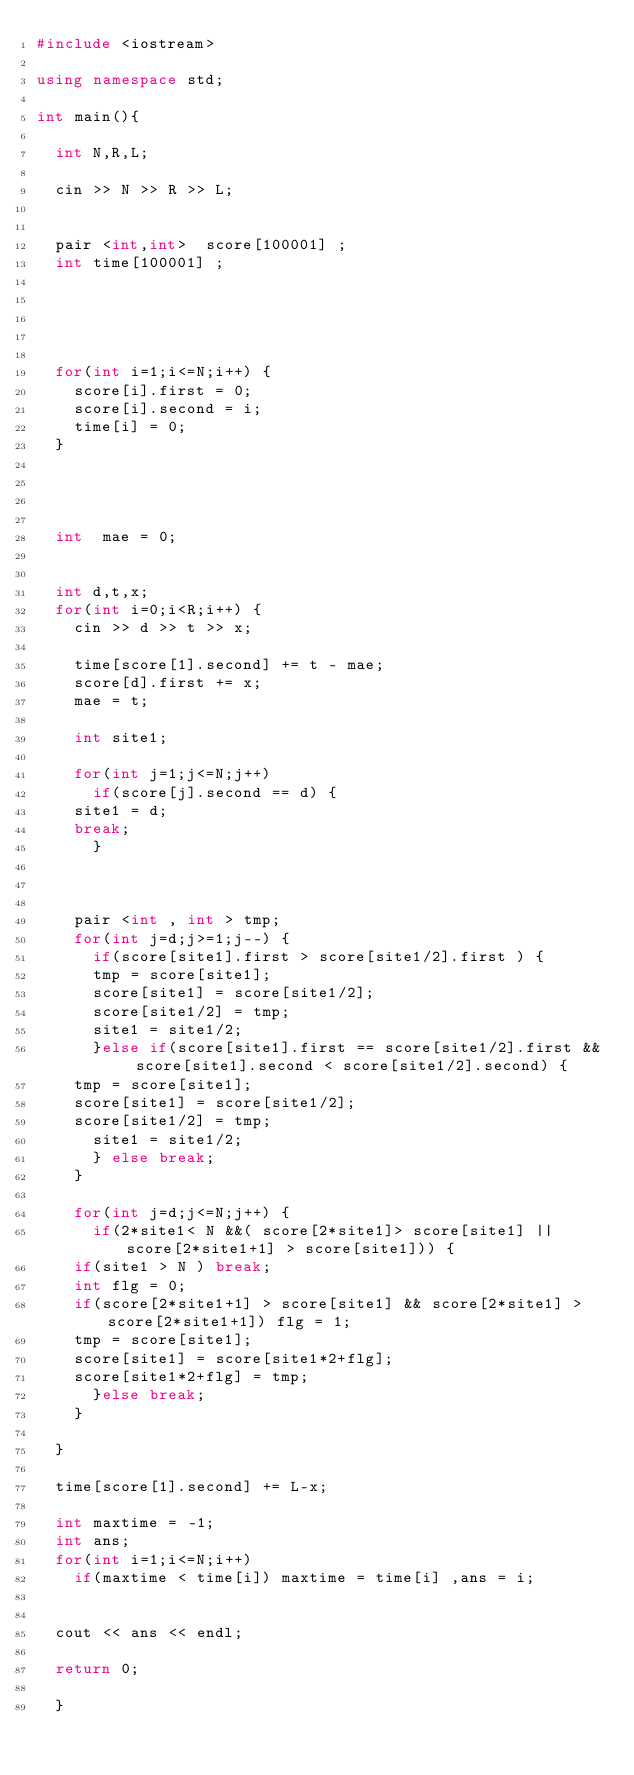Convert code to text. <code><loc_0><loc_0><loc_500><loc_500><_C++_>#include <iostream>

using namespace std;

int main(){

  int N,R,L;

  cin >> N >> R >> L;

  
  pair <int,int>  score[100001] ;
  int time[100001] ;
 

  


  for(int i=1;i<=N;i++) {
    score[i].first = 0;
    score[i].second = i;
    time[i] = 0;
  }
  


  
  int  mae = 0;
  
  
  int d,t,x;
  for(int i=0;i<R;i++) {
    cin >> d >> t >> x;
    
    time[score[1].second] += t - mae;
    score[d].first += x;
    mae = t;
    
    int site1;
    
    for(int j=1;j<=N;j++) 
      if(score[j].second == d) {
	site1 = d;
	break;
      }
    
	 
    
    pair <int , int > tmp;   
    for(int j=d;j>=1;j--) {
      if(score[site1].first > score[site1/2].first ) {
      tmp = score[site1];
      score[site1] = score[site1/2];
      score[site1/2] = tmp;
      site1 = site1/2;
      }else if(score[site1].first == score[site1/2].first && score[site1].second < score[site1/2].second) {
	tmp = score[site1];
	score[site1] = score[site1/2];
	score[site1/2] = tmp;
      site1 = site1/2;
      } else break;
    }
        
    for(int j=d;j<=N;j++) {
      if(2*site1< N &&( score[2*site1]> score[site1] || score[2*site1+1] > score[site1])) {
	if(site1 > N ) break;
	int flg = 0;
	if(score[2*site1+1] > score[site1] && score[2*site1] > score[2*site1+1]) flg = 1;
	tmp = score[site1];
	score[site1] = score[site1*2+flg];
	score[site1*2+flg] = tmp;
      }else break;
    }

  }

  time[score[1].second] += L-x;

  int maxtime = -1;
  int ans;
  for(int i=1;i<=N;i++) 
    if(maxtime < time[i]) maxtime = time[i] ,ans = i;
  
  
  cout << ans << endl;

  return 0;

  }</code> 